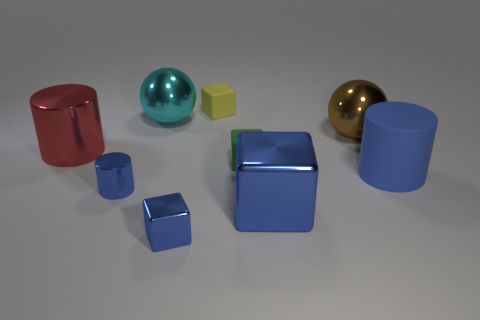What number of matte objects are the same color as the big block?
Ensure brevity in your answer.  1. There is another cylinder that is the same color as the tiny cylinder; what material is it?
Provide a succinct answer. Rubber. Is the shape of the small blue thing that is right of the small blue cylinder the same as  the yellow thing?
Your answer should be very brief. Yes. There is another big object that is the same shape as the cyan thing; what material is it?
Offer a terse response. Metal. What number of objects are either big blue cubes right of the tiny yellow cube or metallic cubes that are right of the tiny yellow rubber object?
Give a very brief answer. 1. Does the matte cylinder have the same color as the small rubber thing behind the green cube?
Your answer should be compact. No. The big red thing that is the same material as the big block is what shape?
Your answer should be compact. Cylinder. How many large purple cylinders are there?
Ensure brevity in your answer.  0. What number of things are objects that are right of the brown shiny ball or small brown matte things?
Provide a succinct answer. 1. Does the cube that is on the left side of the small yellow rubber thing have the same color as the large matte object?
Offer a terse response. Yes. 